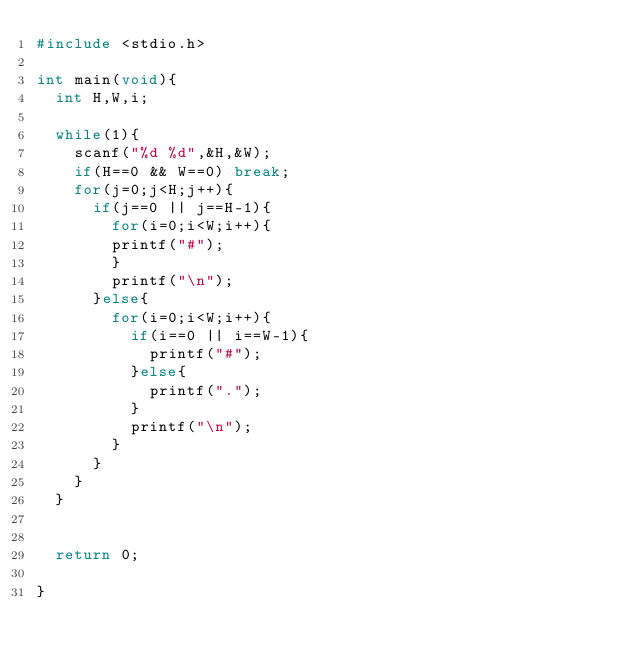Convert code to text. <code><loc_0><loc_0><loc_500><loc_500><_C_>#include <stdio.h>

int main(void){
	int H,W,i;

	while(1){
		scanf("%d %d",&H,&W);
		if(H==0 && W==0) break;
		for(j=0;j<H;j++){
			if(j==0 || j==H-1){
				for(i=0;i<W;i++){
				printf("#");
				}
				printf("\n");
			}else{
				for(i=0;i<W;i++){
					if(i==0 || i==W-1){
						printf("#");
					}else{
						printf(".");
					}
					printf("\n");
				}
			}
		}
	}


	return 0;

}</code> 